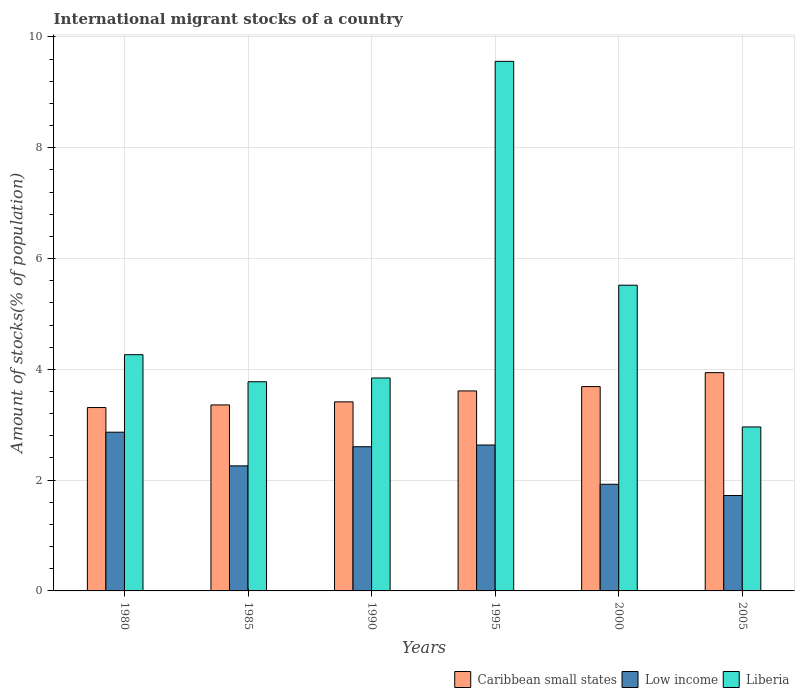How many different coloured bars are there?
Your response must be concise. 3. How many groups of bars are there?
Offer a very short reply. 6. How many bars are there on the 5th tick from the left?
Give a very brief answer. 3. What is the amount of stocks in in Liberia in 1990?
Give a very brief answer. 3.84. Across all years, what is the maximum amount of stocks in in Low income?
Keep it short and to the point. 2.87. Across all years, what is the minimum amount of stocks in in Liberia?
Make the answer very short. 2.96. In which year was the amount of stocks in in Liberia maximum?
Your response must be concise. 1995. What is the total amount of stocks in in Liberia in the graph?
Keep it short and to the point. 29.92. What is the difference between the amount of stocks in in Caribbean small states in 1990 and that in 2000?
Give a very brief answer. -0.28. What is the difference between the amount of stocks in in Low income in 2005 and the amount of stocks in in Caribbean small states in 1980?
Offer a terse response. -1.59. What is the average amount of stocks in in Liberia per year?
Provide a short and direct response. 4.99. In the year 1995, what is the difference between the amount of stocks in in Caribbean small states and amount of stocks in in Low income?
Provide a short and direct response. 0.98. In how many years, is the amount of stocks in in Caribbean small states greater than 6.4 %?
Make the answer very short. 0. What is the ratio of the amount of stocks in in Low income in 1995 to that in 2000?
Make the answer very short. 1.37. Is the amount of stocks in in Liberia in 1980 less than that in 1995?
Your answer should be very brief. Yes. What is the difference between the highest and the second highest amount of stocks in in Low income?
Provide a succinct answer. 0.23. What is the difference between the highest and the lowest amount of stocks in in Low income?
Your answer should be very brief. 1.14. What does the 3rd bar from the left in 2000 represents?
Your answer should be compact. Liberia. What does the 2nd bar from the right in 1985 represents?
Your response must be concise. Low income. How many bars are there?
Your answer should be compact. 18. Are all the bars in the graph horizontal?
Your answer should be compact. No. What is the difference between two consecutive major ticks on the Y-axis?
Offer a very short reply. 2. How many legend labels are there?
Provide a short and direct response. 3. How are the legend labels stacked?
Make the answer very short. Horizontal. What is the title of the graph?
Keep it short and to the point. International migrant stocks of a country. What is the label or title of the Y-axis?
Provide a short and direct response. Amount of stocks(% of population). What is the Amount of stocks(% of population) of Caribbean small states in 1980?
Provide a short and direct response. 3.31. What is the Amount of stocks(% of population) in Low income in 1980?
Offer a very short reply. 2.87. What is the Amount of stocks(% of population) of Liberia in 1980?
Give a very brief answer. 4.26. What is the Amount of stocks(% of population) in Caribbean small states in 1985?
Your response must be concise. 3.36. What is the Amount of stocks(% of population) in Low income in 1985?
Your answer should be very brief. 2.26. What is the Amount of stocks(% of population) of Liberia in 1985?
Offer a terse response. 3.78. What is the Amount of stocks(% of population) of Caribbean small states in 1990?
Your response must be concise. 3.41. What is the Amount of stocks(% of population) of Low income in 1990?
Your answer should be very brief. 2.6. What is the Amount of stocks(% of population) in Liberia in 1990?
Make the answer very short. 3.84. What is the Amount of stocks(% of population) of Caribbean small states in 1995?
Provide a succinct answer. 3.61. What is the Amount of stocks(% of population) in Low income in 1995?
Provide a succinct answer. 2.63. What is the Amount of stocks(% of population) in Liberia in 1995?
Ensure brevity in your answer.  9.56. What is the Amount of stocks(% of population) of Caribbean small states in 2000?
Your response must be concise. 3.69. What is the Amount of stocks(% of population) in Low income in 2000?
Ensure brevity in your answer.  1.93. What is the Amount of stocks(% of population) in Liberia in 2000?
Offer a terse response. 5.52. What is the Amount of stocks(% of population) in Caribbean small states in 2005?
Your response must be concise. 3.94. What is the Amount of stocks(% of population) in Low income in 2005?
Offer a terse response. 1.72. What is the Amount of stocks(% of population) in Liberia in 2005?
Ensure brevity in your answer.  2.96. Across all years, what is the maximum Amount of stocks(% of population) in Caribbean small states?
Your response must be concise. 3.94. Across all years, what is the maximum Amount of stocks(% of population) of Low income?
Give a very brief answer. 2.87. Across all years, what is the maximum Amount of stocks(% of population) in Liberia?
Keep it short and to the point. 9.56. Across all years, what is the minimum Amount of stocks(% of population) of Caribbean small states?
Offer a terse response. 3.31. Across all years, what is the minimum Amount of stocks(% of population) of Low income?
Keep it short and to the point. 1.72. Across all years, what is the minimum Amount of stocks(% of population) in Liberia?
Make the answer very short. 2.96. What is the total Amount of stocks(% of population) in Caribbean small states in the graph?
Provide a succinct answer. 21.32. What is the total Amount of stocks(% of population) of Low income in the graph?
Provide a succinct answer. 14.01. What is the total Amount of stocks(% of population) in Liberia in the graph?
Your answer should be very brief. 29.92. What is the difference between the Amount of stocks(% of population) of Caribbean small states in 1980 and that in 1985?
Give a very brief answer. -0.05. What is the difference between the Amount of stocks(% of population) in Low income in 1980 and that in 1985?
Provide a short and direct response. 0.61. What is the difference between the Amount of stocks(% of population) in Liberia in 1980 and that in 1985?
Make the answer very short. 0.49. What is the difference between the Amount of stocks(% of population) of Caribbean small states in 1980 and that in 1990?
Your answer should be very brief. -0.1. What is the difference between the Amount of stocks(% of population) of Low income in 1980 and that in 1990?
Your answer should be very brief. 0.26. What is the difference between the Amount of stocks(% of population) of Liberia in 1980 and that in 1990?
Keep it short and to the point. 0.42. What is the difference between the Amount of stocks(% of population) in Caribbean small states in 1980 and that in 1995?
Make the answer very short. -0.3. What is the difference between the Amount of stocks(% of population) of Low income in 1980 and that in 1995?
Keep it short and to the point. 0.23. What is the difference between the Amount of stocks(% of population) of Liberia in 1980 and that in 1995?
Keep it short and to the point. -5.3. What is the difference between the Amount of stocks(% of population) in Caribbean small states in 1980 and that in 2000?
Keep it short and to the point. -0.38. What is the difference between the Amount of stocks(% of population) in Liberia in 1980 and that in 2000?
Ensure brevity in your answer.  -1.25. What is the difference between the Amount of stocks(% of population) of Caribbean small states in 1980 and that in 2005?
Make the answer very short. -0.63. What is the difference between the Amount of stocks(% of population) in Low income in 1980 and that in 2005?
Keep it short and to the point. 1.14. What is the difference between the Amount of stocks(% of population) in Liberia in 1980 and that in 2005?
Provide a short and direct response. 1.3. What is the difference between the Amount of stocks(% of population) of Caribbean small states in 1985 and that in 1990?
Offer a very short reply. -0.06. What is the difference between the Amount of stocks(% of population) of Low income in 1985 and that in 1990?
Keep it short and to the point. -0.35. What is the difference between the Amount of stocks(% of population) in Liberia in 1985 and that in 1990?
Give a very brief answer. -0.07. What is the difference between the Amount of stocks(% of population) in Caribbean small states in 1985 and that in 1995?
Keep it short and to the point. -0.25. What is the difference between the Amount of stocks(% of population) of Low income in 1985 and that in 1995?
Keep it short and to the point. -0.38. What is the difference between the Amount of stocks(% of population) in Liberia in 1985 and that in 1995?
Offer a terse response. -5.78. What is the difference between the Amount of stocks(% of population) in Caribbean small states in 1985 and that in 2000?
Keep it short and to the point. -0.33. What is the difference between the Amount of stocks(% of population) of Low income in 1985 and that in 2000?
Ensure brevity in your answer.  0.33. What is the difference between the Amount of stocks(% of population) of Liberia in 1985 and that in 2000?
Ensure brevity in your answer.  -1.74. What is the difference between the Amount of stocks(% of population) of Caribbean small states in 1985 and that in 2005?
Provide a succinct answer. -0.58. What is the difference between the Amount of stocks(% of population) in Low income in 1985 and that in 2005?
Your response must be concise. 0.53. What is the difference between the Amount of stocks(% of population) of Liberia in 1985 and that in 2005?
Ensure brevity in your answer.  0.82. What is the difference between the Amount of stocks(% of population) in Caribbean small states in 1990 and that in 1995?
Keep it short and to the point. -0.2. What is the difference between the Amount of stocks(% of population) in Low income in 1990 and that in 1995?
Give a very brief answer. -0.03. What is the difference between the Amount of stocks(% of population) in Liberia in 1990 and that in 1995?
Provide a succinct answer. -5.72. What is the difference between the Amount of stocks(% of population) of Caribbean small states in 1990 and that in 2000?
Provide a succinct answer. -0.28. What is the difference between the Amount of stocks(% of population) in Low income in 1990 and that in 2000?
Give a very brief answer. 0.68. What is the difference between the Amount of stocks(% of population) of Liberia in 1990 and that in 2000?
Give a very brief answer. -1.67. What is the difference between the Amount of stocks(% of population) in Caribbean small states in 1990 and that in 2005?
Provide a succinct answer. -0.53. What is the difference between the Amount of stocks(% of population) of Low income in 1990 and that in 2005?
Your response must be concise. 0.88. What is the difference between the Amount of stocks(% of population) in Liberia in 1990 and that in 2005?
Give a very brief answer. 0.88. What is the difference between the Amount of stocks(% of population) in Caribbean small states in 1995 and that in 2000?
Provide a succinct answer. -0.08. What is the difference between the Amount of stocks(% of population) in Low income in 1995 and that in 2000?
Ensure brevity in your answer.  0.71. What is the difference between the Amount of stocks(% of population) in Liberia in 1995 and that in 2000?
Provide a succinct answer. 4.04. What is the difference between the Amount of stocks(% of population) of Caribbean small states in 1995 and that in 2005?
Offer a terse response. -0.33. What is the difference between the Amount of stocks(% of population) in Low income in 1995 and that in 2005?
Provide a succinct answer. 0.91. What is the difference between the Amount of stocks(% of population) in Liberia in 1995 and that in 2005?
Your answer should be compact. 6.6. What is the difference between the Amount of stocks(% of population) in Caribbean small states in 2000 and that in 2005?
Your answer should be compact. -0.25. What is the difference between the Amount of stocks(% of population) of Low income in 2000 and that in 2005?
Keep it short and to the point. 0.2. What is the difference between the Amount of stocks(% of population) of Liberia in 2000 and that in 2005?
Your answer should be compact. 2.56. What is the difference between the Amount of stocks(% of population) of Caribbean small states in 1980 and the Amount of stocks(% of population) of Low income in 1985?
Keep it short and to the point. 1.05. What is the difference between the Amount of stocks(% of population) of Caribbean small states in 1980 and the Amount of stocks(% of population) of Liberia in 1985?
Keep it short and to the point. -0.47. What is the difference between the Amount of stocks(% of population) in Low income in 1980 and the Amount of stocks(% of population) in Liberia in 1985?
Ensure brevity in your answer.  -0.91. What is the difference between the Amount of stocks(% of population) in Caribbean small states in 1980 and the Amount of stocks(% of population) in Low income in 1990?
Make the answer very short. 0.71. What is the difference between the Amount of stocks(% of population) in Caribbean small states in 1980 and the Amount of stocks(% of population) in Liberia in 1990?
Your answer should be compact. -0.53. What is the difference between the Amount of stocks(% of population) of Low income in 1980 and the Amount of stocks(% of population) of Liberia in 1990?
Keep it short and to the point. -0.98. What is the difference between the Amount of stocks(% of population) in Caribbean small states in 1980 and the Amount of stocks(% of population) in Low income in 1995?
Give a very brief answer. 0.68. What is the difference between the Amount of stocks(% of population) in Caribbean small states in 1980 and the Amount of stocks(% of population) in Liberia in 1995?
Keep it short and to the point. -6.25. What is the difference between the Amount of stocks(% of population) in Low income in 1980 and the Amount of stocks(% of population) in Liberia in 1995?
Your response must be concise. -6.69. What is the difference between the Amount of stocks(% of population) in Caribbean small states in 1980 and the Amount of stocks(% of population) in Low income in 2000?
Your answer should be very brief. 1.39. What is the difference between the Amount of stocks(% of population) of Caribbean small states in 1980 and the Amount of stocks(% of population) of Liberia in 2000?
Give a very brief answer. -2.21. What is the difference between the Amount of stocks(% of population) of Low income in 1980 and the Amount of stocks(% of population) of Liberia in 2000?
Give a very brief answer. -2.65. What is the difference between the Amount of stocks(% of population) in Caribbean small states in 1980 and the Amount of stocks(% of population) in Low income in 2005?
Keep it short and to the point. 1.59. What is the difference between the Amount of stocks(% of population) of Caribbean small states in 1980 and the Amount of stocks(% of population) of Liberia in 2005?
Offer a terse response. 0.35. What is the difference between the Amount of stocks(% of population) of Low income in 1980 and the Amount of stocks(% of population) of Liberia in 2005?
Give a very brief answer. -0.09. What is the difference between the Amount of stocks(% of population) of Caribbean small states in 1985 and the Amount of stocks(% of population) of Low income in 1990?
Keep it short and to the point. 0.75. What is the difference between the Amount of stocks(% of population) of Caribbean small states in 1985 and the Amount of stocks(% of population) of Liberia in 1990?
Give a very brief answer. -0.49. What is the difference between the Amount of stocks(% of population) in Low income in 1985 and the Amount of stocks(% of population) in Liberia in 1990?
Give a very brief answer. -1.59. What is the difference between the Amount of stocks(% of population) in Caribbean small states in 1985 and the Amount of stocks(% of population) in Low income in 1995?
Provide a short and direct response. 0.72. What is the difference between the Amount of stocks(% of population) of Caribbean small states in 1985 and the Amount of stocks(% of population) of Liberia in 1995?
Provide a succinct answer. -6.2. What is the difference between the Amount of stocks(% of population) of Low income in 1985 and the Amount of stocks(% of population) of Liberia in 1995?
Provide a succinct answer. -7.3. What is the difference between the Amount of stocks(% of population) of Caribbean small states in 1985 and the Amount of stocks(% of population) of Low income in 2000?
Offer a very short reply. 1.43. What is the difference between the Amount of stocks(% of population) of Caribbean small states in 1985 and the Amount of stocks(% of population) of Liberia in 2000?
Ensure brevity in your answer.  -2.16. What is the difference between the Amount of stocks(% of population) in Low income in 1985 and the Amount of stocks(% of population) in Liberia in 2000?
Offer a very short reply. -3.26. What is the difference between the Amount of stocks(% of population) of Caribbean small states in 1985 and the Amount of stocks(% of population) of Low income in 2005?
Provide a succinct answer. 1.64. What is the difference between the Amount of stocks(% of population) of Caribbean small states in 1985 and the Amount of stocks(% of population) of Liberia in 2005?
Provide a succinct answer. 0.4. What is the difference between the Amount of stocks(% of population) of Low income in 1985 and the Amount of stocks(% of population) of Liberia in 2005?
Make the answer very short. -0.7. What is the difference between the Amount of stocks(% of population) of Caribbean small states in 1990 and the Amount of stocks(% of population) of Low income in 1995?
Your response must be concise. 0.78. What is the difference between the Amount of stocks(% of population) of Caribbean small states in 1990 and the Amount of stocks(% of population) of Liberia in 1995?
Offer a very short reply. -6.15. What is the difference between the Amount of stocks(% of population) of Low income in 1990 and the Amount of stocks(% of population) of Liberia in 1995?
Your answer should be compact. -6.96. What is the difference between the Amount of stocks(% of population) in Caribbean small states in 1990 and the Amount of stocks(% of population) in Low income in 2000?
Offer a terse response. 1.49. What is the difference between the Amount of stocks(% of population) of Caribbean small states in 1990 and the Amount of stocks(% of population) of Liberia in 2000?
Provide a succinct answer. -2.11. What is the difference between the Amount of stocks(% of population) in Low income in 1990 and the Amount of stocks(% of population) in Liberia in 2000?
Make the answer very short. -2.92. What is the difference between the Amount of stocks(% of population) of Caribbean small states in 1990 and the Amount of stocks(% of population) of Low income in 2005?
Make the answer very short. 1.69. What is the difference between the Amount of stocks(% of population) of Caribbean small states in 1990 and the Amount of stocks(% of population) of Liberia in 2005?
Make the answer very short. 0.45. What is the difference between the Amount of stocks(% of population) of Low income in 1990 and the Amount of stocks(% of population) of Liberia in 2005?
Your answer should be compact. -0.36. What is the difference between the Amount of stocks(% of population) in Caribbean small states in 1995 and the Amount of stocks(% of population) in Low income in 2000?
Give a very brief answer. 1.69. What is the difference between the Amount of stocks(% of population) of Caribbean small states in 1995 and the Amount of stocks(% of population) of Liberia in 2000?
Your response must be concise. -1.91. What is the difference between the Amount of stocks(% of population) in Low income in 1995 and the Amount of stocks(% of population) in Liberia in 2000?
Your response must be concise. -2.88. What is the difference between the Amount of stocks(% of population) of Caribbean small states in 1995 and the Amount of stocks(% of population) of Low income in 2005?
Offer a very short reply. 1.89. What is the difference between the Amount of stocks(% of population) in Caribbean small states in 1995 and the Amount of stocks(% of population) in Liberia in 2005?
Provide a succinct answer. 0.65. What is the difference between the Amount of stocks(% of population) of Low income in 1995 and the Amount of stocks(% of population) of Liberia in 2005?
Give a very brief answer. -0.33. What is the difference between the Amount of stocks(% of population) in Caribbean small states in 2000 and the Amount of stocks(% of population) in Low income in 2005?
Provide a succinct answer. 1.97. What is the difference between the Amount of stocks(% of population) of Caribbean small states in 2000 and the Amount of stocks(% of population) of Liberia in 2005?
Your answer should be very brief. 0.73. What is the difference between the Amount of stocks(% of population) of Low income in 2000 and the Amount of stocks(% of population) of Liberia in 2005?
Provide a succinct answer. -1.03. What is the average Amount of stocks(% of population) of Caribbean small states per year?
Give a very brief answer. 3.55. What is the average Amount of stocks(% of population) of Low income per year?
Your answer should be compact. 2.33. What is the average Amount of stocks(% of population) in Liberia per year?
Your response must be concise. 4.99. In the year 1980, what is the difference between the Amount of stocks(% of population) in Caribbean small states and Amount of stocks(% of population) in Low income?
Your answer should be compact. 0.45. In the year 1980, what is the difference between the Amount of stocks(% of population) in Caribbean small states and Amount of stocks(% of population) in Liberia?
Your answer should be compact. -0.95. In the year 1980, what is the difference between the Amount of stocks(% of population) of Low income and Amount of stocks(% of population) of Liberia?
Ensure brevity in your answer.  -1.4. In the year 1985, what is the difference between the Amount of stocks(% of population) of Caribbean small states and Amount of stocks(% of population) of Low income?
Make the answer very short. 1.1. In the year 1985, what is the difference between the Amount of stocks(% of population) of Caribbean small states and Amount of stocks(% of population) of Liberia?
Your answer should be very brief. -0.42. In the year 1985, what is the difference between the Amount of stocks(% of population) in Low income and Amount of stocks(% of population) in Liberia?
Give a very brief answer. -1.52. In the year 1990, what is the difference between the Amount of stocks(% of population) of Caribbean small states and Amount of stocks(% of population) of Low income?
Keep it short and to the point. 0.81. In the year 1990, what is the difference between the Amount of stocks(% of population) of Caribbean small states and Amount of stocks(% of population) of Liberia?
Keep it short and to the point. -0.43. In the year 1990, what is the difference between the Amount of stocks(% of population) of Low income and Amount of stocks(% of population) of Liberia?
Ensure brevity in your answer.  -1.24. In the year 1995, what is the difference between the Amount of stocks(% of population) of Caribbean small states and Amount of stocks(% of population) of Low income?
Ensure brevity in your answer.  0.98. In the year 1995, what is the difference between the Amount of stocks(% of population) in Caribbean small states and Amount of stocks(% of population) in Liberia?
Your response must be concise. -5.95. In the year 1995, what is the difference between the Amount of stocks(% of population) in Low income and Amount of stocks(% of population) in Liberia?
Make the answer very short. -6.93. In the year 2000, what is the difference between the Amount of stocks(% of population) of Caribbean small states and Amount of stocks(% of population) of Low income?
Make the answer very short. 1.76. In the year 2000, what is the difference between the Amount of stocks(% of population) of Caribbean small states and Amount of stocks(% of population) of Liberia?
Make the answer very short. -1.83. In the year 2000, what is the difference between the Amount of stocks(% of population) in Low income and Amount of stocks(% of population) in Liberia?
Your response must be concise. -3.59. In the year 2005, what is the difference between the Amount of stocks(% of population) in Caribbean small states and Amount of stocks(% of population) in Low income?
Offer a very short reply. 2.22. In the year 2005, what is the difference between the Amount of stocks(% of population) of Caribbean small states and Amount of stocks(% of population) of Liberia?
Provide a succinct answer. 0.98. In the year 2005, what is the difference between the Amount of stocks(% of population) of Low income and Amount of stocks(% of population) of Liberia?
Offer a terse response. -1.24. What is the ratio of the Amount of stocks(% of population) of Caribbean small states in 1980 to that in 1985?
Provide a short and direct response. 0.99. What is the ratio of the Amount of stocks(% of population) of Low income in 1980 to that in 1985?
Your answer should be very brief. 1.27. What is the ratio of the Amount of stocks(% of population) of Liberia in 1980 to that in 1985?
Provide a short and direct response. 1.13. What is the ratio of the Amount of stocks(% of population) in Caribbean small states in 1980 to that in 1990?
Your answer should be very brief. 0.97. What is the ratio of the Amount of stocks(% of population) in Low income in 1980 to that in 1990?
Ensure brevity in your answer.  1.1. What is the ratio of the Amount of stocks(% of population) of Liberia in 1980 to that in 1990?
Offer a terse response. 1.11. What is the ratio of the Amount of stocks(% of population) in Caribbean small states in 1980 to that in 1995?
Provide a succinct answer. 0.92. What is the ratio of the Amount of stocks(% of population) of Low income in 1980 to that in 1995?
Provide a short and direct response. 1.09. What is the ratio of the Amount of stocks(% of population) of Liberia in 1980 to that in 1995?
Your response must be concise. 0.45. What is the ratio of the Amount of stocks(% of population) in Caribbean small states in 1980 to that in 2000?
Provide a short and direct response. 0.9. What is the ratio of the Amount of stocks(% of population) of Low income in 1980 to that in 2000?
Your response must be concise. 1.49. What is the ratio of the Amount of stocks(% of population) of Liberia in 1980 to that in 2000?
Provide a short and direct response. 0.77. What is the ratio of the Amount of stocks(% of population) of Caribbean small states in 1980 to that in 2005?
Give a very brief answer. 0.84. What is the ratio of the Amount of stocks(% of population) of Low income in 1980 to that in 2005?
Give a very brief answer. 1.66. What is the ratio of the Amount of stocks(% of population) of Liberia in 1980 to that in 2005?
Ensure brevity in your answer.  1.44. What is the ratio of the Amount of stocks(% of population) of Caribbean small states in 1985 to that in 1990?
Provide a short and direct response. 0.98. What is the ratio of the Amount of stocks(% of population) of Low income in 1985 to that in 1990?
Make the answer very short. 0.87. What is the ratio of the Amount of stocks(% of population) in Liberia in 1985 to that in 1990?
Provide a succinct answer. 0.98. What is the ratio of the Amount of stocks(% of population) of Caribbean small states in 1985 to that in 1995?
Your answer should be very brief. 0.93. What is the ratio of the Amount of stocks(% of population) of Low income in 1985 to that in 1995?
Keep it short and to the point. 0.86. What is the ratio of the Amount of stocks(% of population) of Liberia in 1985 to that in 1995?
Your answer should be compact. 0.4. What is the ratio of the Amount of stocks(% of population) of Caribbean small states in 1985 to that in 2000?
Provide a succinct answer. 0.91. What is the ratio of the Amount of stocks(% of population) in Low income in 1985 to that in 2000?
Offer a terse response. 1.17. What is the ratio of the Amount of stocks(% of population) in Liberia in 1985 to that in 2000?
Your answer should be very brief. 0.68. What is the ratio of the Amount of stocks(% of population) of Caribbean small states in 1985 to that in 2005?
Your answer should be compact. 0.85. What is the ratio of the Amount of stocks(% of population) in Low income in 1985 to that in 2005?
Offer a very short reply. 1.31. What is the ratio of the Amount of stocks(% of population) of Liberia in 1985 to that in 2005?
Give a very brief answer. 1.28. What is the ratio of the Amount of stocks(% of population) of Caribbean small states in 1990 to that in 1995?
Your answer should be very brief. 0.95. What is the ratio of the Amount of stocks(% of population) of Liberia in 1990 to that in 1995?
Give a very brief answer. 0.4. What is the ratio of the Amount of stocks(% of population) of Caribbean small states in 1990 to that in 2000?
Make the answer very short. 0.93. What is the ratio of the Amount of stocks(% of population) of Low income in 1990 to that in 2000?
Offer a very short reply. 1.35. What is the ratio of the Amount of stocks(% of population) of Liberia in 1990 to that in 2000?
Offer a terse response. 0.7. What is the ratio of the Amount of stocks(% of population) of Caribbean small states in 1990 to that in 2005?
Give a very brief answer. 0.87. What is the ratio of the Amount of stocks(% of population) of Low income in 1990 to that in 2005?
Offer a terse response. 1.51. What is the ratio of the Amount of stocks(% of population) in Liberia in 1990 to that in 2005?
Make the answer very short. 1.3. What is the ratio of the Amount of stocks(% of population) in Caribbean small states in 1995 to that in 2000?
Give a very brief answer. 0.98. What is the ratio of the Amount of stocks(% of population) of Low income in 1995 to that in 2000?
Offer a terse response. 1.37. What is the ratio of the Amount of stocks(% of population) of Liberia in 1995 to that in 2000?
Your answer should be compact. 1.73. What is the ratio of the Amount of stocks(% of population) of Caribbean small states in 1995 to that in 2005?
Provide a short and direct response. 0.92. What is the ratio of the Amount of stocks(% of population) of Low income in 1995 to that in 2005?
Make the answer very short. 1.53. What is the ratio of the Amount of stocks(% of population) in Liberia in 1995 to that in 2005?
Make the answer very short. 3.23. What is the ratio of the Amount of stocks(% of population) of Caribbean small states in 2000 to that in 2005?
Provide a succinct answer. 0.94. What is the ratio of the Amount of stocks(% of population) in Low income in 2000 to that in 2005?
Provide a succinct answer. 1.12. What is the ratio of the Amount of stocks(% of population) of Liberia in 2000 to that in 2005?
Your answer should be compact. 1.86. What is the difference between the highest and the second highest Amount of stocks(% of population) in Caribbean small states?
Offer a terse response. 0.25. What is the difference between the highest and the second highest Amount of stocks(% of population) of Low income?
Your response must be concise. 0.23. What is the difference between the highest and the second highest Amount of stocks(% of population) of Liberia?
Make the answer very short. 4.04. What is the difference between the highest and the lowest Amount of stocks(% of population) in Caribbean small states?
Make the answer very short. 0.63. What is the difference between the highest and the lowest Amount of stocks(% of population) in Low income?
Your response must be concise. 1.14. What is the difference between the highest and the lowest Amount of stocks(% of population) in Liberia?
Your response must be concise. 6.6. 